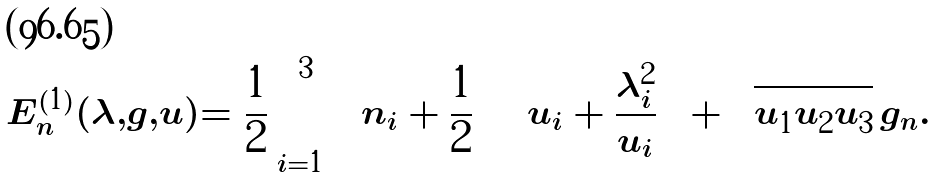<formula> <loc_0><loc_0><loc_500><loc_500>E _ { n } ^ { ( 1 ) } ( \lambda , g , u ) = \frac { 1 } { 2 } \sum _ { i = 1 } ^ { 3 } \left ( n _ { i } + \frac { 1 } { 2 } \right ) \left ( u _ { i } + \frac { \lambda _ { i } ^ { 2 } } { u _ { i } } \right ) + \sqrt { u _ { 1 } u _ { 2 } u _ { 3 } } \, g _ { n } .</formula> 